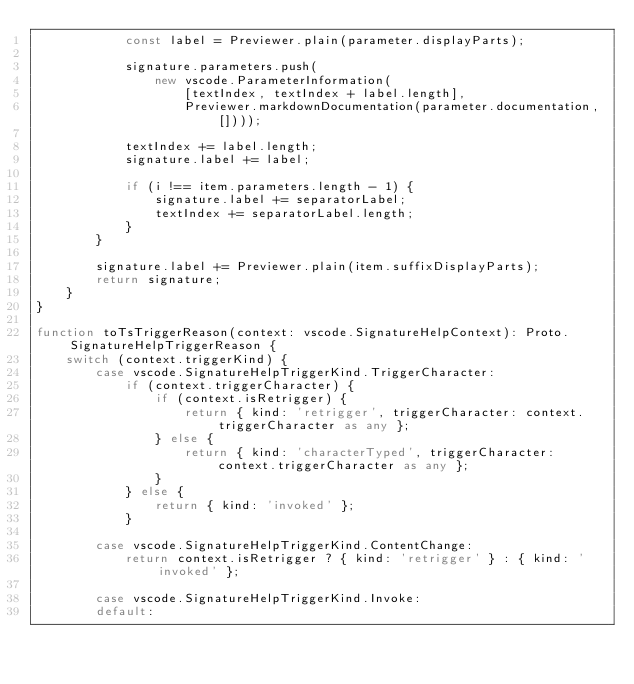<code> <loc_0><loc_0><loc_500><loc_500><_TypeScript_>			const label = Previewer.plain(parameter.displayParts);

			signature.parameters.push(
				new vscode.ParameterInformation(
					[textIndex, textIndex + label.length],
					Previewer.markdownDocumentation(parameter.documentation, [])));

			textIndex += label.length;
			signature.label += label;

			if (i !== item.parameters.length - 1) {
				signature.label += separatorLabel;
				textIndex += separatorLabel.length;
			}
		}

		signature.label += Previewer.plain(item.suffixDisplayParts);
		return signature;
	}
}

function toTsTriggerReason(context: vscode.SignatureHelpContext): Proto.SignatureHelpTriggerReason {
	switch (context.triggerKind) {
		case vscode.SignatureHelpTriggerKind.TriggerCharacter:
			if (context.triggerCharacter) {
				if (context.isRetrigger) {
					return { kind: 'retrigger', triggerCharacter: context.triggerCharacter as any };
				} else {
					return { kind: 'characterTyped', triggerCharacter: context.triggerCharacter as any };
				}
			} else {
				return { kind: 'invoked' };
			}

		case vscode.SignatureHelpTriggerKind.ContentChange:
			return context.isRetrigger ? { kind: 'retrigger' } : { kind: 'invoked' };

		case vscode.SignatureHelpTriggerKind.Invoke:
		default:</code> 